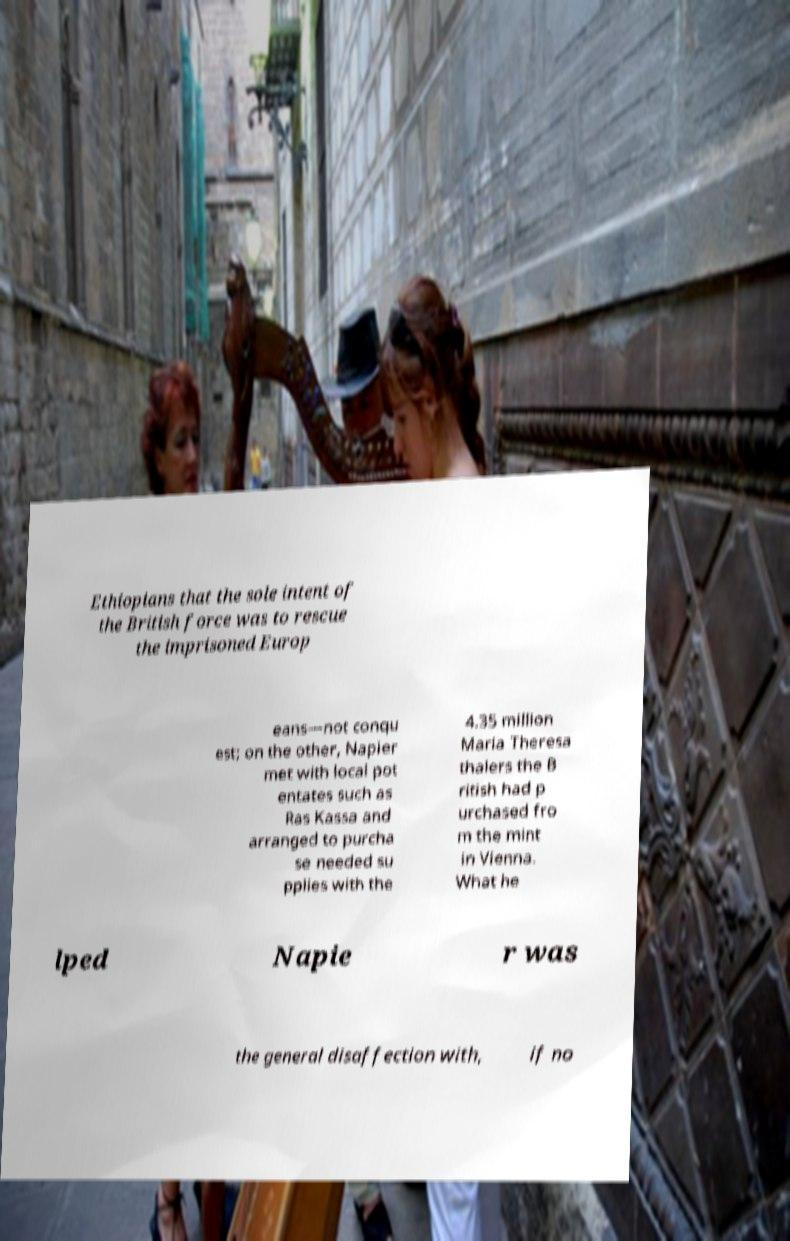I need the written content from this picture converted into text. Can you do that? Ethiopians that the sole intent of the British force was to rescue the imprisoned Europ eans—not conqu est; on the other, Napier met with local pot entates such as Ras Kassa and arranged to purcha se needed su pplies with the 4.35 million Maria Theresa thalers the B ritish had p urchased fro m the mint in Vienna. What he lped Napie r was the general disaffection with, if no 